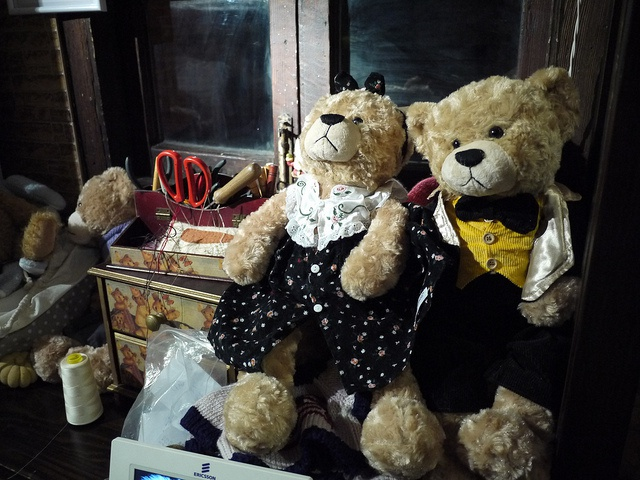Describe the objects in this image and their specific colors. I can see teddy bear in black, tan, ivory, and gray tones, teddy bear in black, gray, olive, and tan tones, teddy bear in black and gray tones, tie in black and olive tones, and scissors in black, maroon, red, and brown tones in this image. 